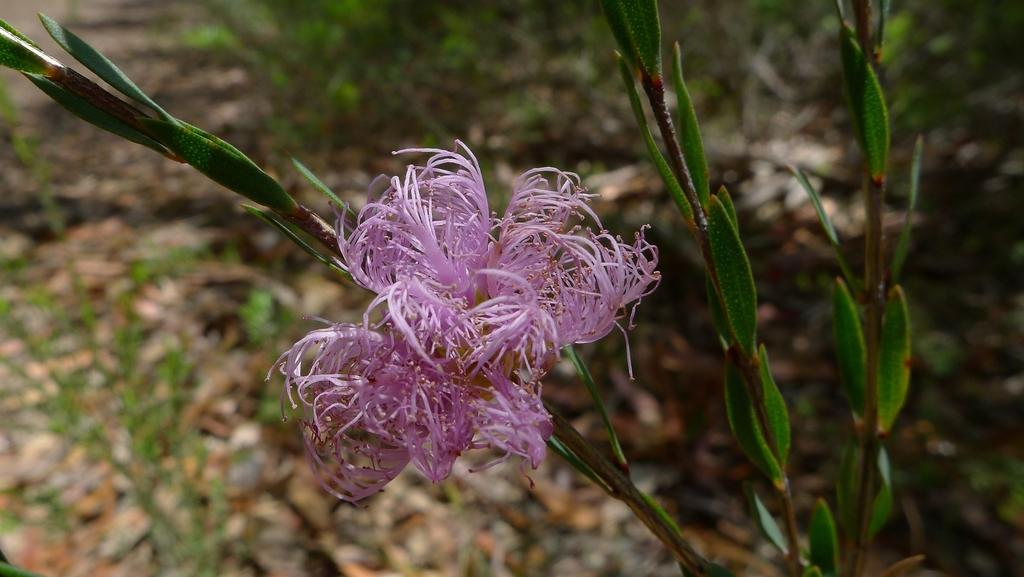What type of plant is featured in the image? There is a plant with a flower in the image. What can be seen in the background of the image? There is grass visible in the background of the image. How many apples are hanging from the plant in the image? There are no apples present in the image; it features a plant with a flower. Is there a crown visible on the plant in the image? There is no crown present in the image; it features a plant with a flower. 